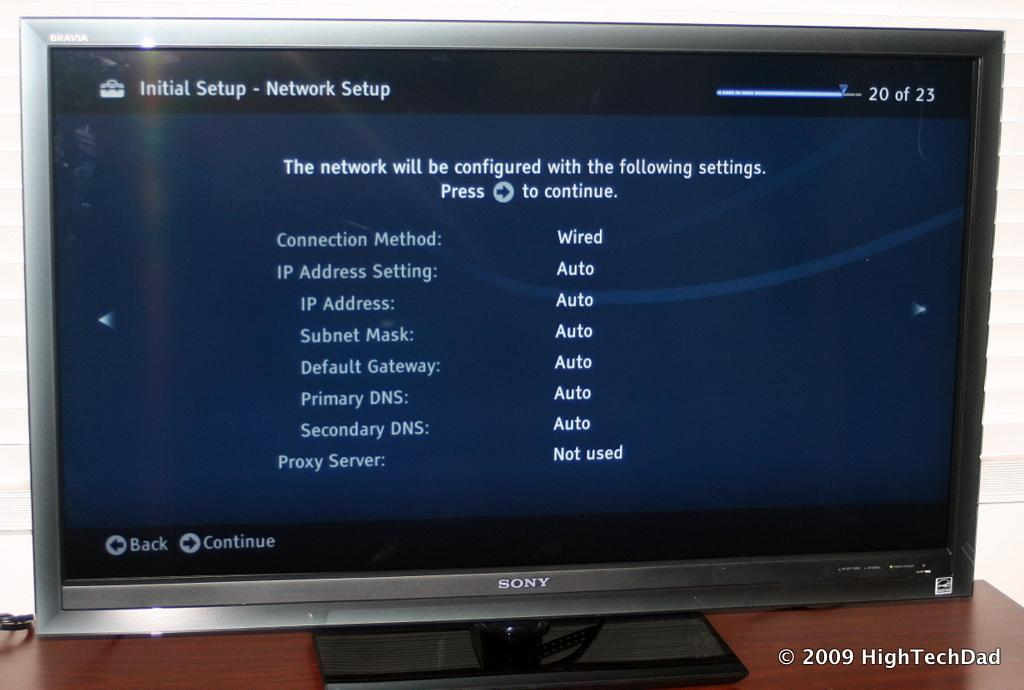<image>
Give a short and clear explanation of the subsequent image. The television is connected by wire and is not using a Proxy Server. 